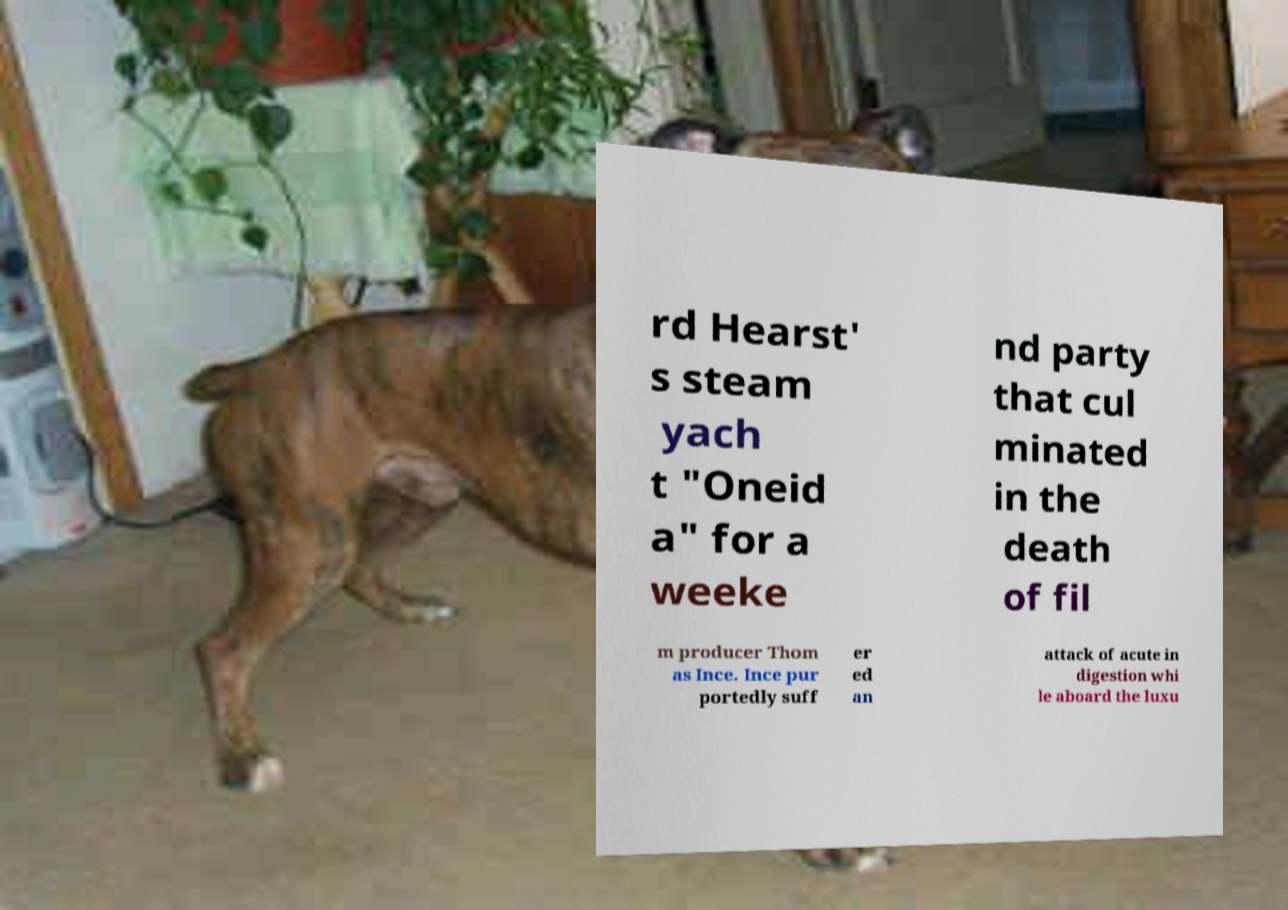There's text embedded in this image that I need extracted. Can you transcribe it verbatim? rd Hearst' s steam yach t "Oneid a" for a weeke nd party that cul minated in the death of fil m producer Thom as Ince. Ince pur portedly suff er ed an attack of acute in digestion whi le aboard the luxu 